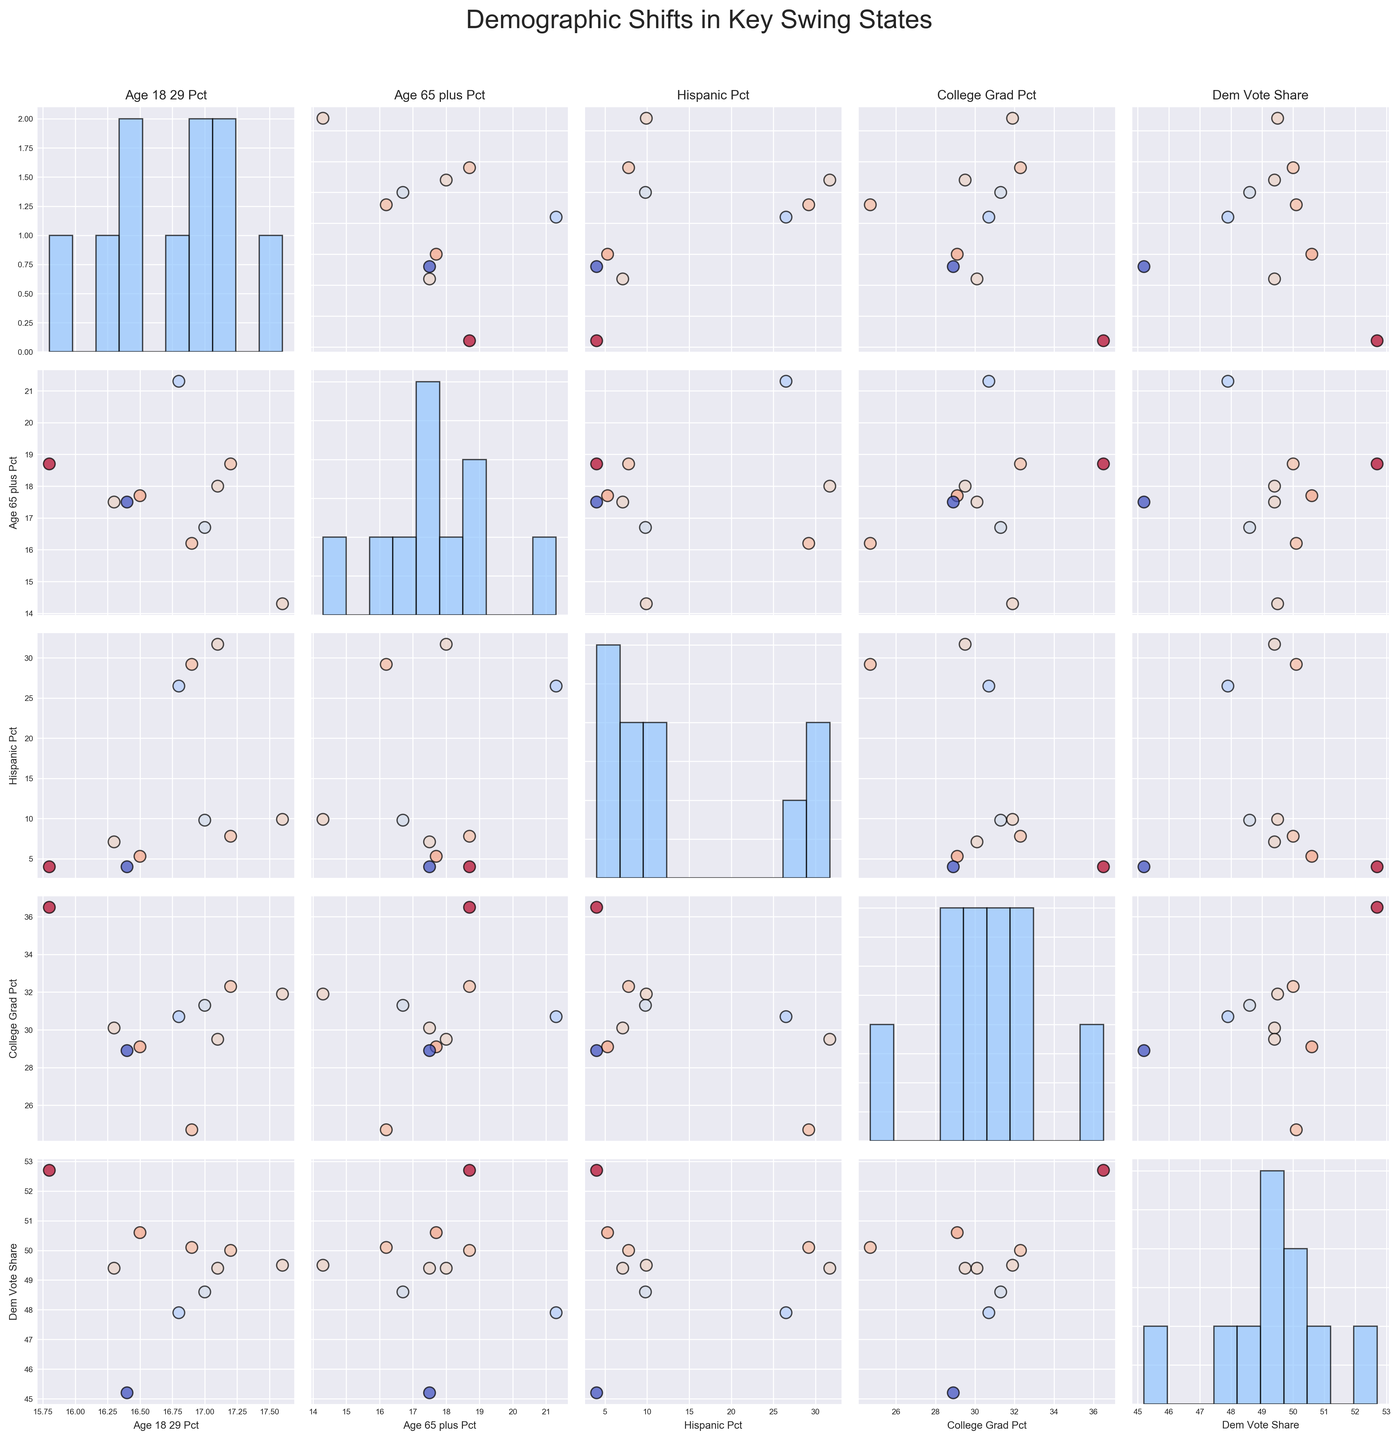What is the title of the figure? The title of the plot is located at the top of the figure and helps to provide context about the visualized data. The title reads: "Demographic Shifts in Key Swing States".
Answer: Demographic Shifts in Key Swing States How are the different variables visually distinguished in the scatterplots? The scatterplots use colors to represent the 'Dem_Vote_Share' variable, with a colormap ranging from cool to warm tones, indicating the Democratic vote share in each state. Moreover, each scatterplot compares different pairs of variables from the dataset.
Answer: Colors and axes labels Which swing state has the highest percentage of college graduates? By looking at the histogram along the diagonal for 'College_Grad_Pct', the highest value represents New Hampshire with clearly the leading percentage.
Answer: New Hampshire Comparing 'Age_65_plus_Pct' and 'Dem_Vote_Share', which state shows the highest 'Dem_Vote_Share'? By looking at the scatterplot from the row labeled 'Age_65_plus_Pct' and the column labeled 'Dem_Vote_Share', identify that the highest Democratic vote share corresponds to New Hampshire.
Answer: New Hampshire What is the relationship between 'Hispanic_Pct' and 'Dem_Vote_Share'? On the scatterplot for 'Hispanic_Pct' vs. 'Dem_Vote_Share', we see points spread across the plot with a slight positive trend, indicating a possible but not strong correlation where higher Hispanic percentage might be associated with a higher Democratic vote share.
Answer: Slight positive trend Which state has the largest Hispanic percentage? By examining the histogram on the diagonal for 'Hispanic_Pct', the state with the largest percentage of Hispanic population is Arizona.
Answer: Arizona Is there any state with a greater than 50% Democratic vote share and above 30% college graduates? Cross-referencing the scatterplot between 'College_Grad_Pct' on the x-axis and 'Dem_Vote_Share' on the y-axis, identify that New Hampshire fits this criterion.
Answer: New Hampshire Does a higher percentage of the age group 18-29 correlate with a higher 'Dem_Vote_Share'? By analyzing the scatterplot between 'Age_18_29_Pct' and 'Dem_Vote_Share', the dots show no clear trend or obvious correlation between these two variables.
Answer: No clear correlation Which state has the lowest Democratic vote share and what is its percentage of the 65+ age group? By identifying the scatterplot point that indicates the lowest 'Dem_Vote_Share', and cross-referencing this point with the "% Age 65+" axis, the lowest Democratic vote share is by Ohio, with about 17.5% of its population being 65+ years old.
Answer: Ohio, 17.5% What can you conclude about the distribution of 'Dem_Vote_Share'? Observing the histogram on the diagonal for 'Dem_Vote_Share', the distribution appears to be fairly spread out across a range from about 45% to over 50%, indicating some variability in Democratic support among the swing states.
Answer: Fairly wide range 